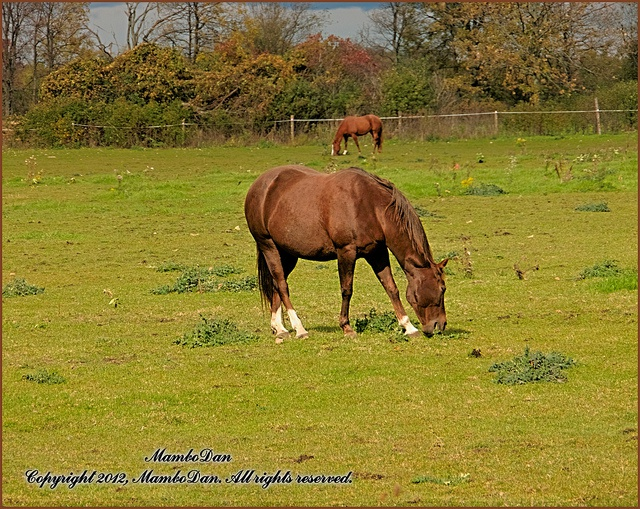Describe the objects in this image and their specific colors. I can see horse in brown, maroon, black, and salmon tones and horse in brown, maroon, black, and olive tones in this image. 